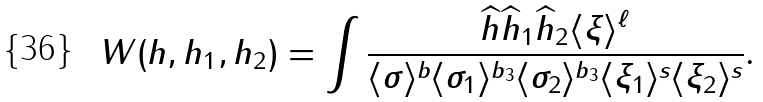<formula> <loc_0><loc_0><loc_500><loc_500>W ( h , h _ { 1 } , h _ { 2 } ) = \int \frac { \widehat { h } \widehat { h } _ { 1 } \widehat { h } _ { 2 } \langle \xi \rangle ^ { \ell } } { \langle \sigma \rangle ^ { b } \langle \sigma _ { 1 } \rangle ^ { b _ { 3 } } \langle \sigma _ { 2 } \rangle ^ { b _ { 3 } } \langle \xi _ { 1 } \rangle ^ { s } \langle \xi _ { 2 } \rangle ^ { s } } .</formula> 